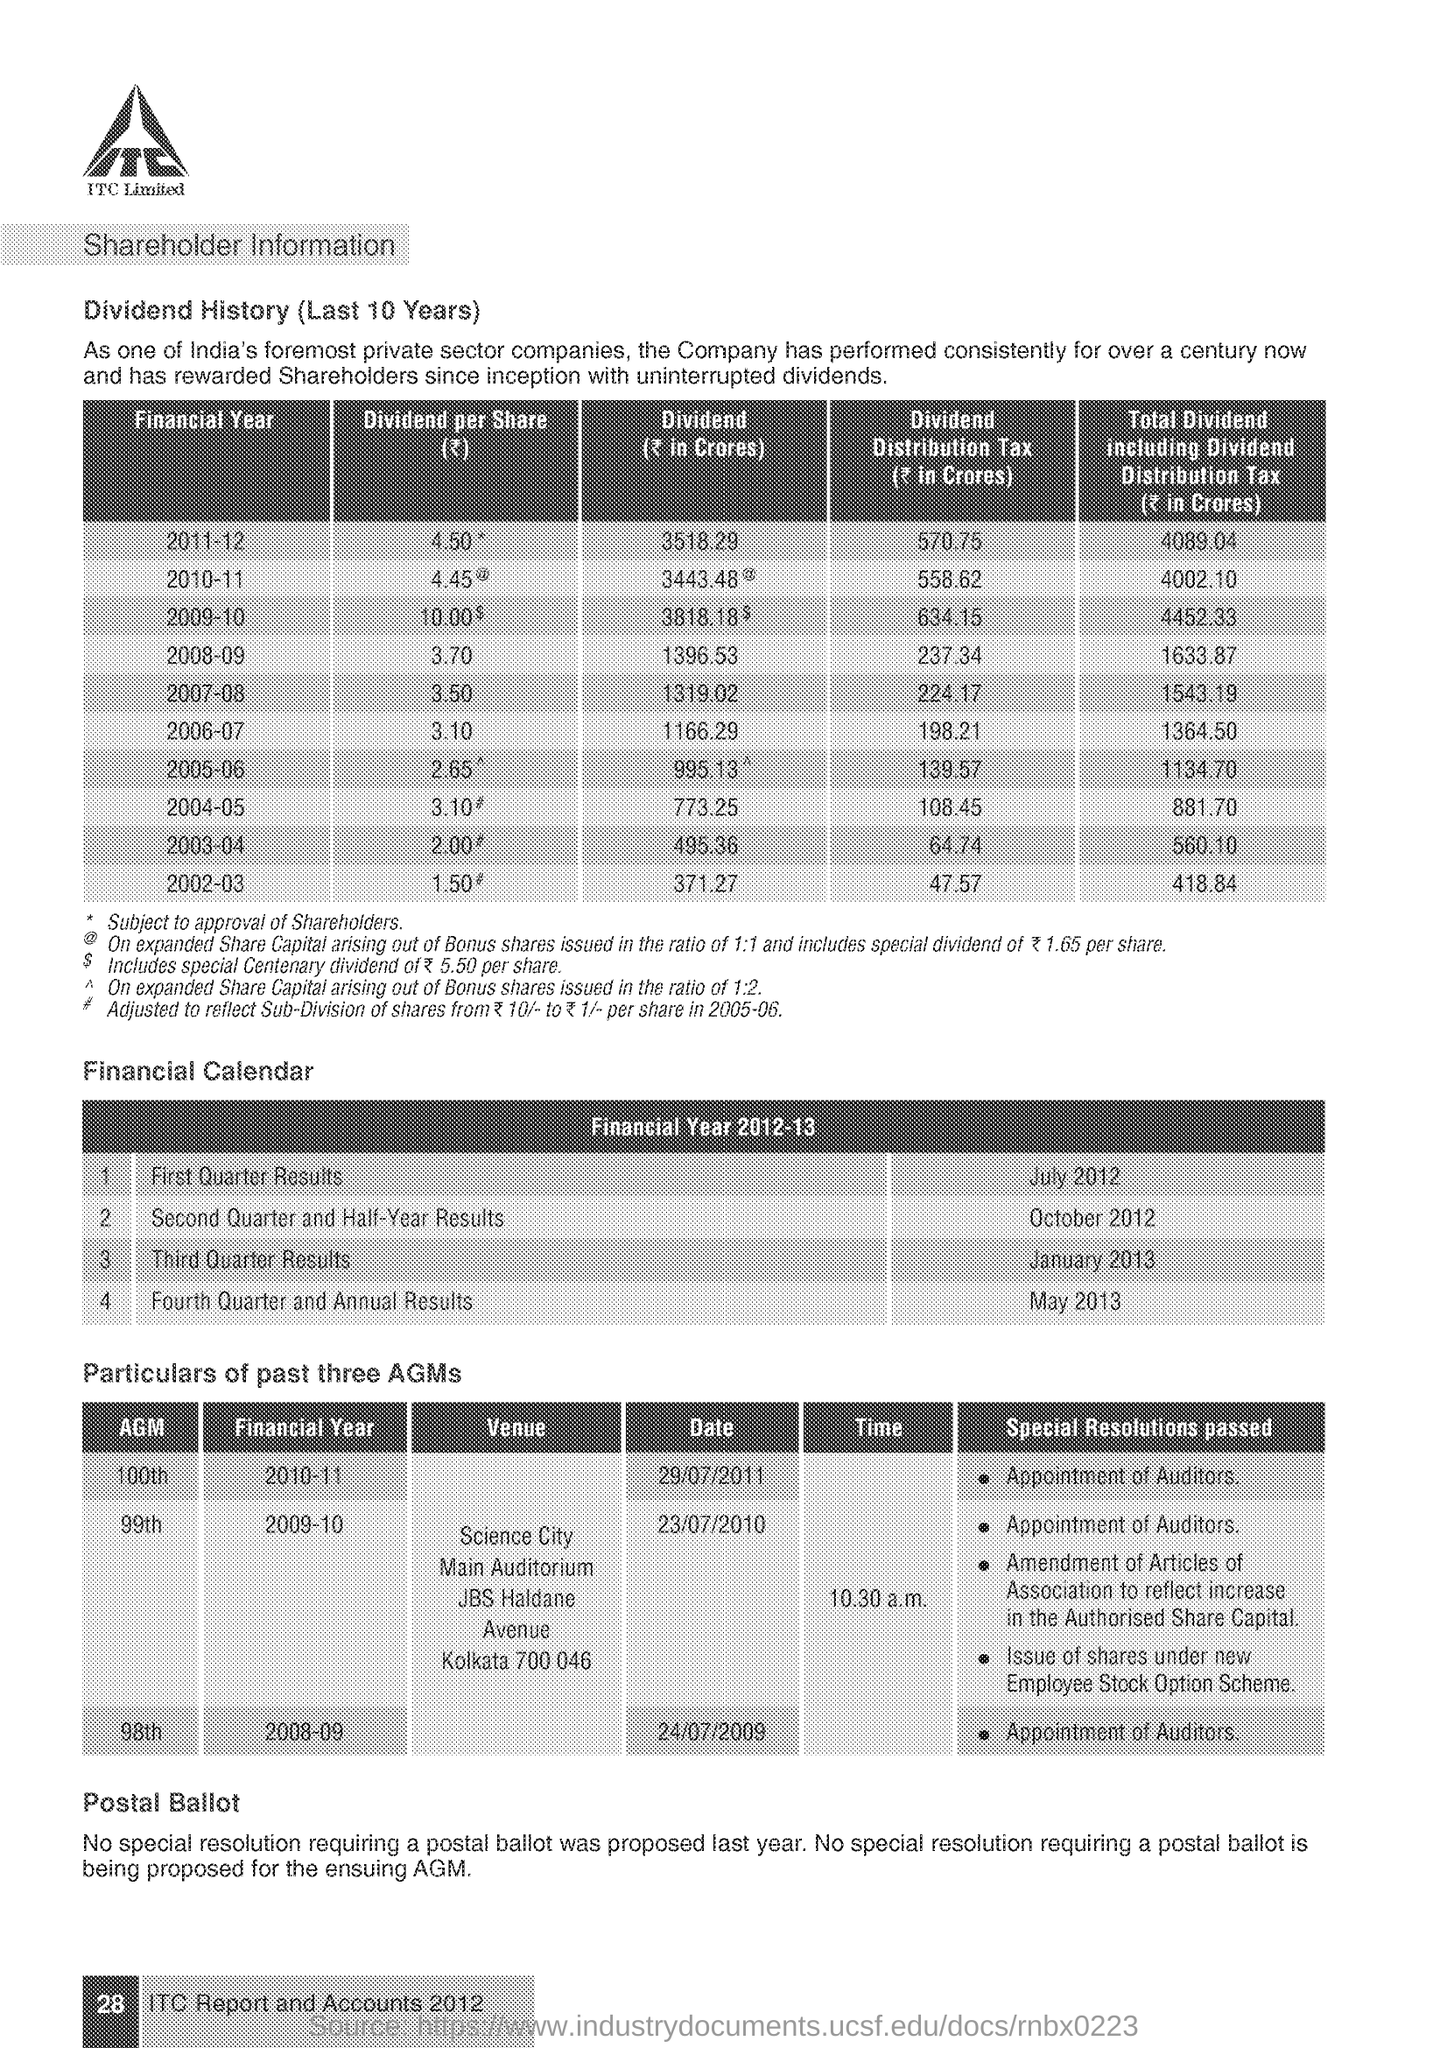According to financial year calendar the first quarter results will be published on which month?
Your response must be concise. July. 